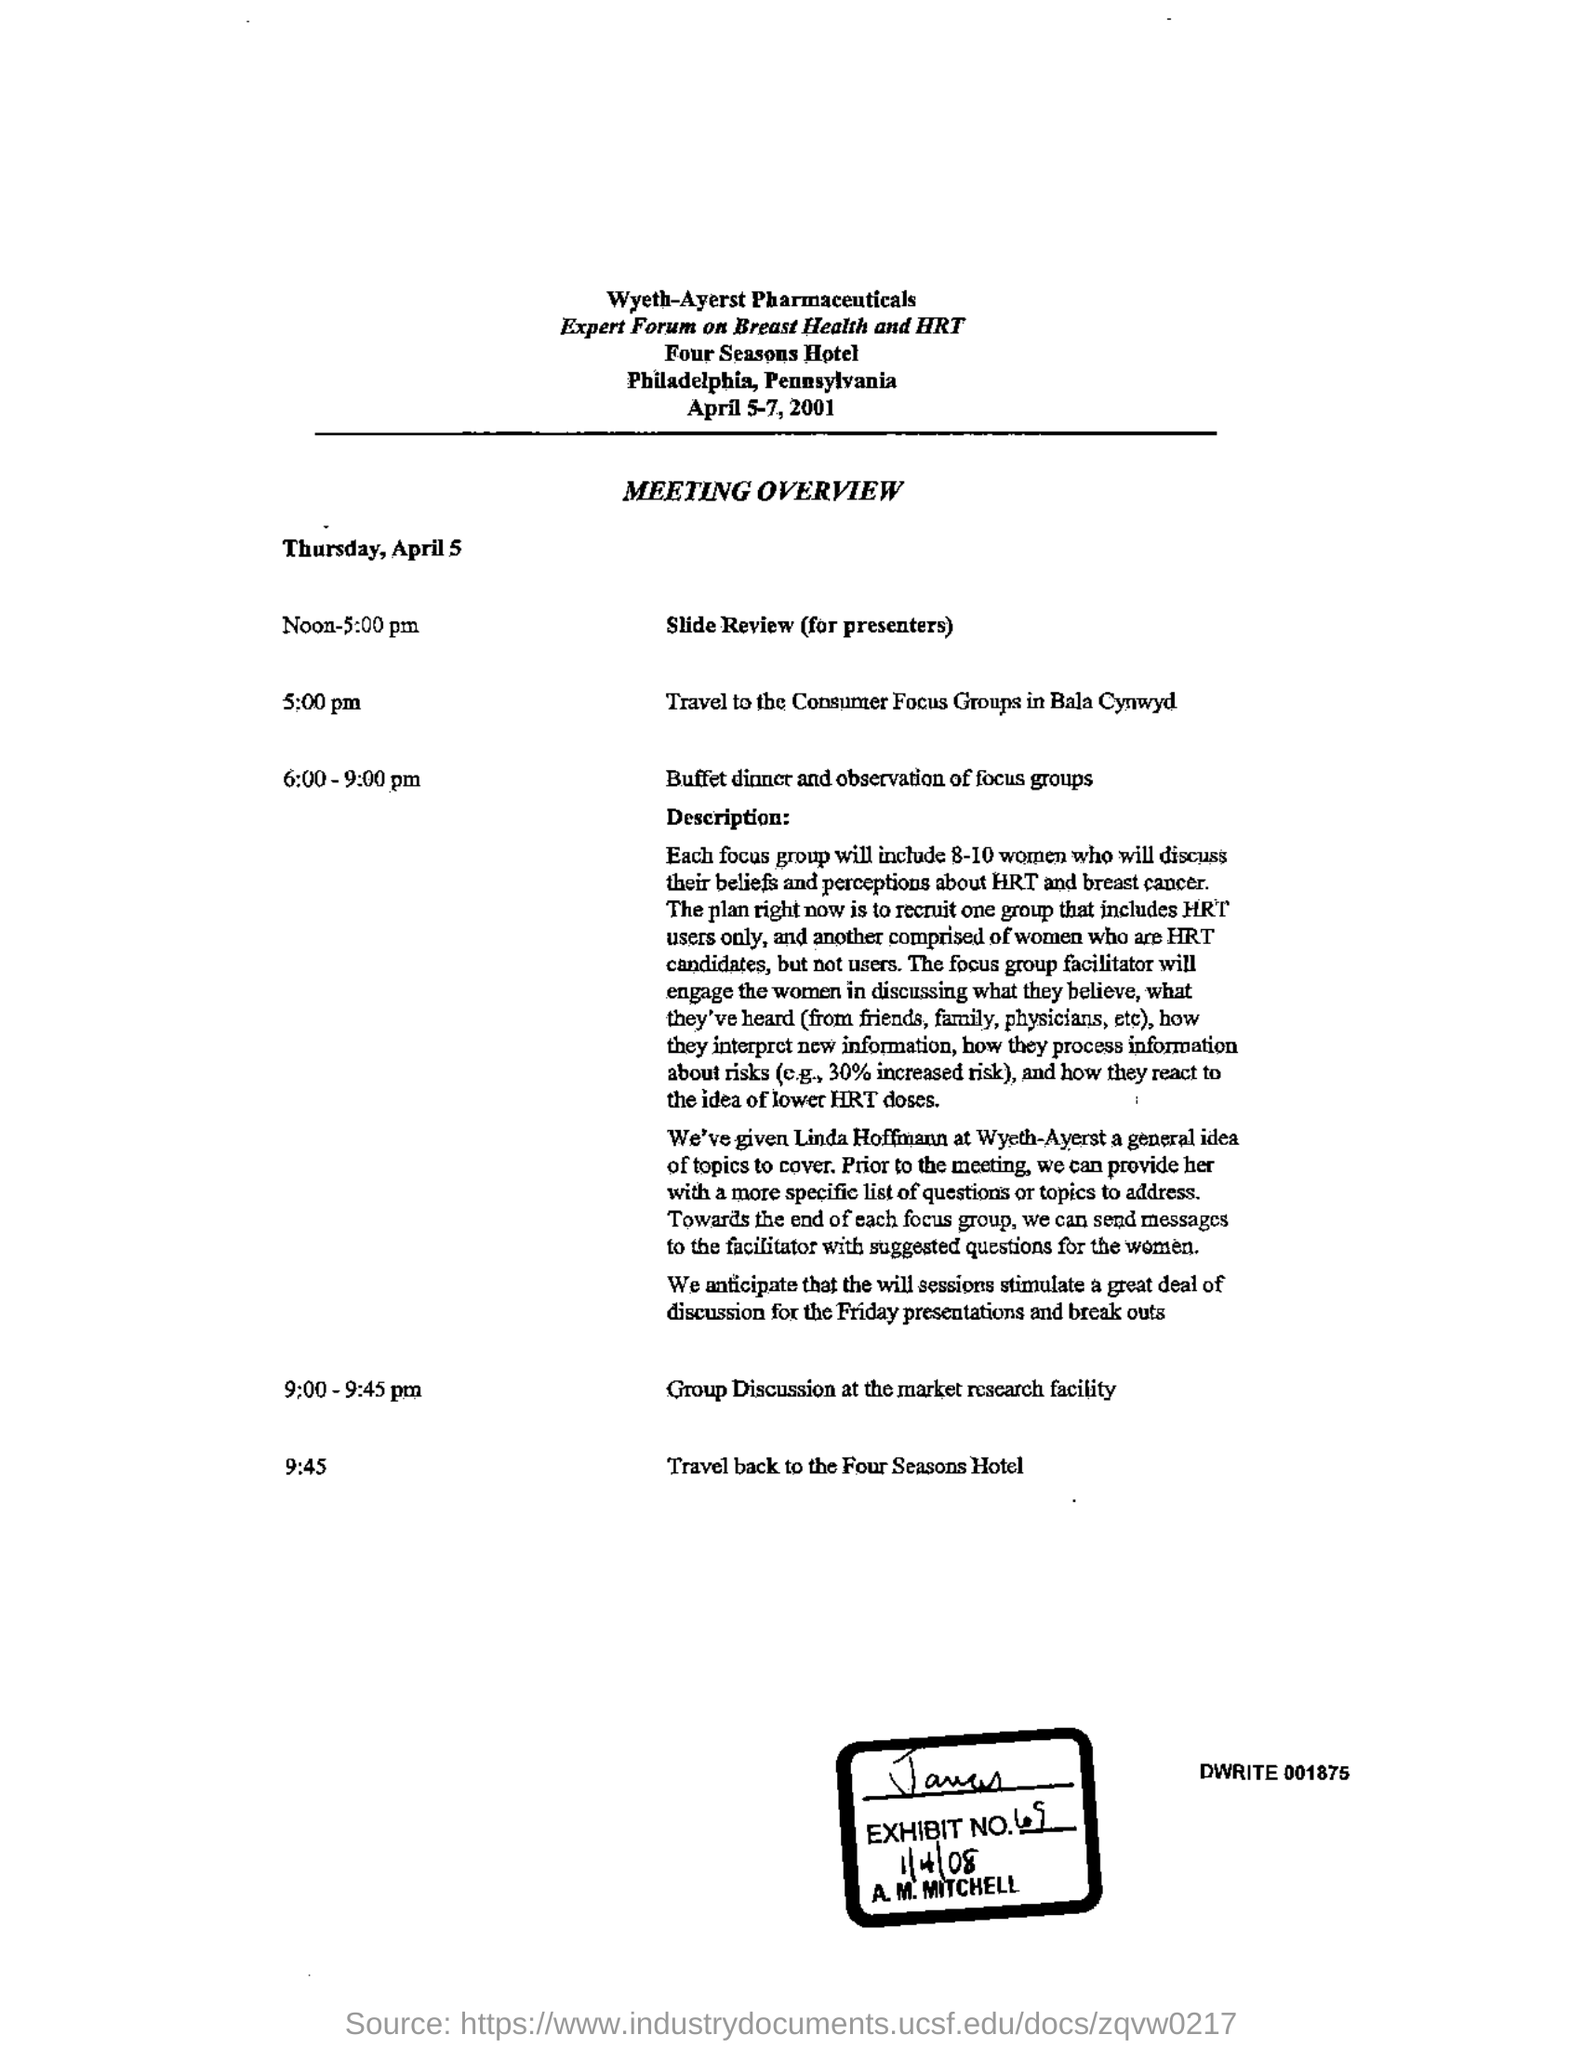What is the Exhibit number?
Your answer should be very brief. 69. 